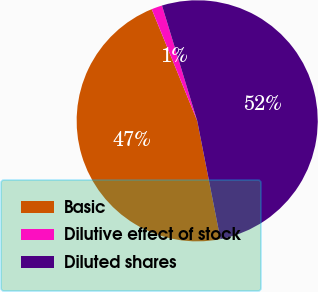<chart> <loc_0><loc_0><loc_500><loc_500><pie_chart><fcel>Basic<fcel>Dilutive effect of stock<fcel>Diluted shares<nl><fcel>46.93%<fcel>1.44%<fcel>51.63%<nl></chart> 